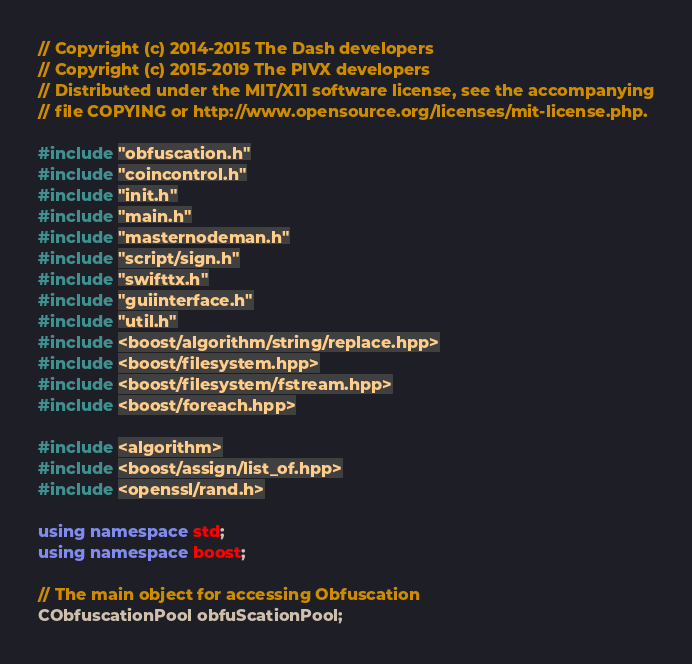<code> <loc_0><loc_0><loc_500><loc_500><_C++_>// Copyright (c) 2014-2015 The Dash developers
// Copyright (c) 2015-2019 The PIVX developers
// Distributed under the MIT/X11 software license, see the accompanying
// file COPYING or http://www.opensource.org/licenses/mit-license.php.

#include "obfuscation.h"
#include "coincontrol.h"
#include "init.h"
#include "main.h"
#include "masternodeman.h"
#include "script/sign.h"
#include "swifttx.h"
#include "guiinterface.h"
#include "util.h"
#include <boost/algorithm/string/replace.hpp>
#include <boost/filesystem.hpp>
#include <boost/filesystem/fstream.hpp>
#include <boost/foreach.hpp>

#include <algorithm>
#include <boost/assign/list_of.hpp>
#include <openssl/rand.h>

using namespace std;
using namespace boost;

// The main object for accessing Obfuscation
CObfuscationPool obfuScationPool;</code> 